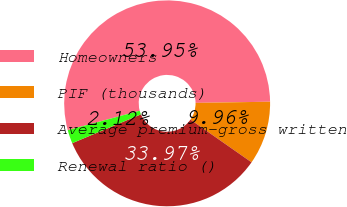<chart> <loc_0><loc_0><loc_500><loc_500><pie_chart><fcel>Homeowners<fcel>PIF (thousands)<fcel>Average premium-gross written<fcel>Renewal ratio ()<nl><fcel>53.95%<fcel>9.96%<fcel>33.97%<fcel>2.12%<nl></chart> 